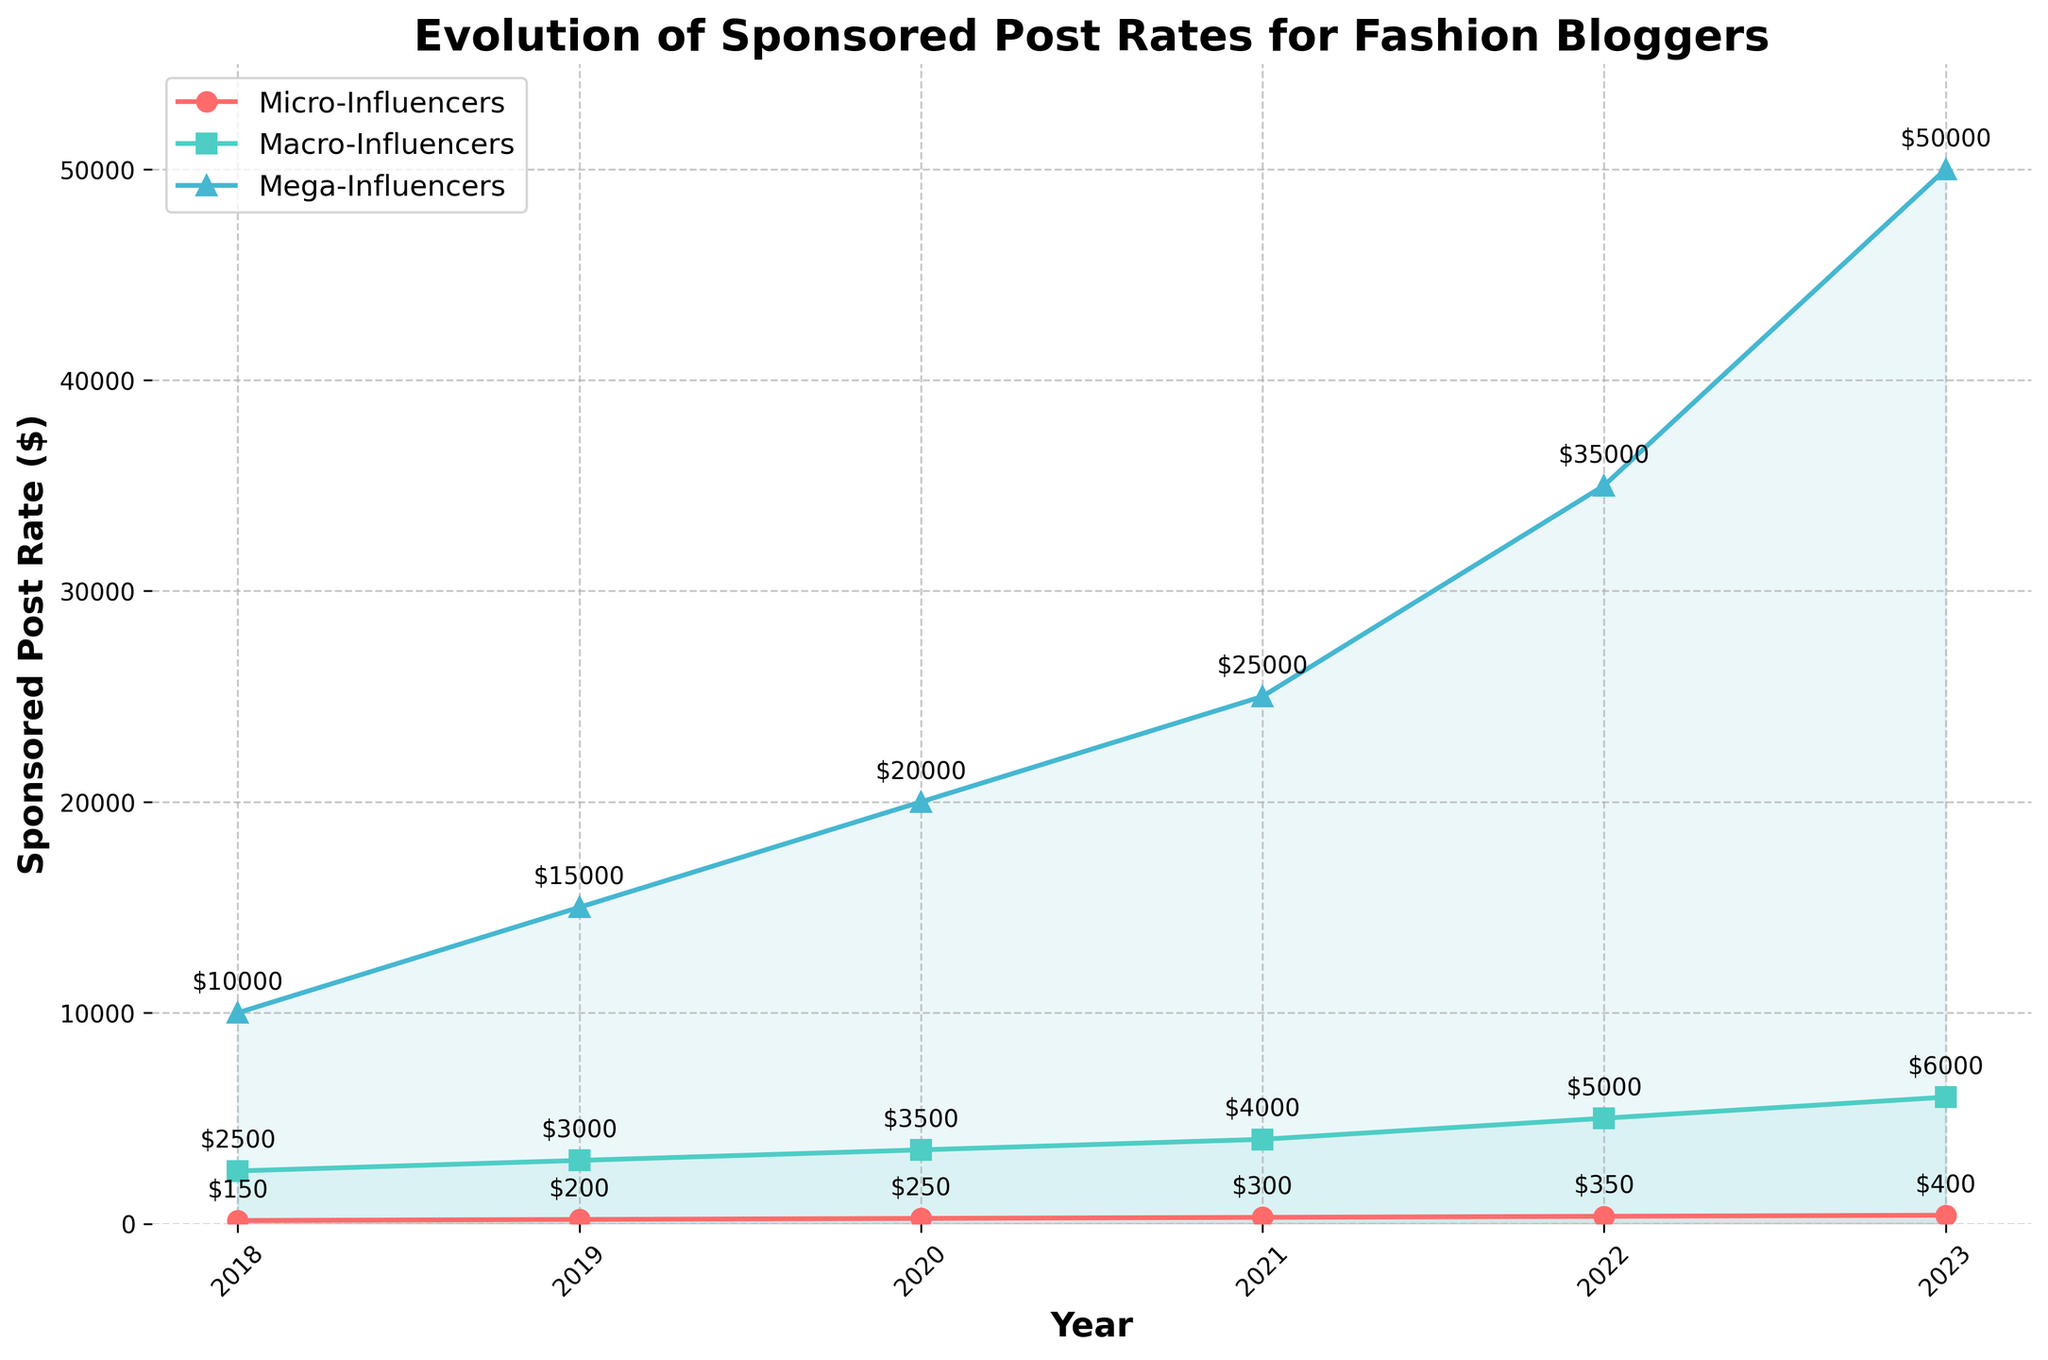Which influencer tier had the highest sponsored post rate in 2023? Look at the graph for the year 2023 and identify which tier's line is at the highest point. The Mega-Influencers tier has the highest value.
Answer: Mega-Influencers How did the sponsored post rate for Macro-Influencers change from 2019 to 2022? Compare the value of the Macro-Influencers line in 2019 to its value in 2022. In 2019, it is at $3000, and in 2022, it is at $5000. Subtract the 2019 value from the 2022 value ($5000 - $3000).
Answer: Increased by $2000 What was the difference in the sponsored post rate between Micro-Influencers and Mega-Influencers in 2020? Locate the values for both tiers in 2020. Micro-Influencers is at $250, and Mega-Influencers is at $20000. Subtract the Micro-Influencers value from the Mega-Influencers value ($20000 - $250).
Answer: $19750 Which tier showed the most consistent increase over the years? Consistent increase means a steady, uniform rise in values year-on-year. Observe the lines for all three tiers and identify which has the least fluctuation and a uniform upward trend. The Micro-Influencers line shows the most consistent increase.
Answer: Micro-Influencers What is the average sponsored post rate for Macro-Influencers from 2018 to 2023? Add the post rates for Macro-Influencers for each year from 2018 to 2023 (2500 + 3000 + 3500 + 4000 + 5000 + 6000). Then, divide the sum by the number of years (6).
Answer: $4000 Between which two consecutive years did Mega-Influencers see the largest increase in sponsored post rates? Calculate the year-on-year increase for Mega-Influencers for each pair of consecutive years (2018-2019, 2019-2020, etc.). Identify the pair with the highest increase:
(2019-2018: 15000-10000 = 5000),
(2020-2019: 20000-15000 = 5000),
(2021-2020: 25000-20000 = 5000),
(2022-2021: 35000-25000 = 10000),
(2023-2022: 50000-35000 = 15000).
Answer: 2022-2023 What color represents the Micro-Influencers data line on the chart? Looking at the plotted lines and their corresponding legend, identify the color associated with Micro-Influencers. The line for Micro-Influencers is marked red.
Answer: Red What visual marker is used for the Macro-Influencers line? Refer to the chart legend to find the shape or type of marker used for the Macro-Influencers line. The macro-influencers line uses a square marker.
Answer: Square In which year did the Micro-Influencers reach a sponsored post rate of $300? Identify the year on the x-axis where the line for Micro-Influencers crosses the $300 mark on the y-axis. The Micro-Influencers line reaches $300 in 2021.
Answer: 2021 